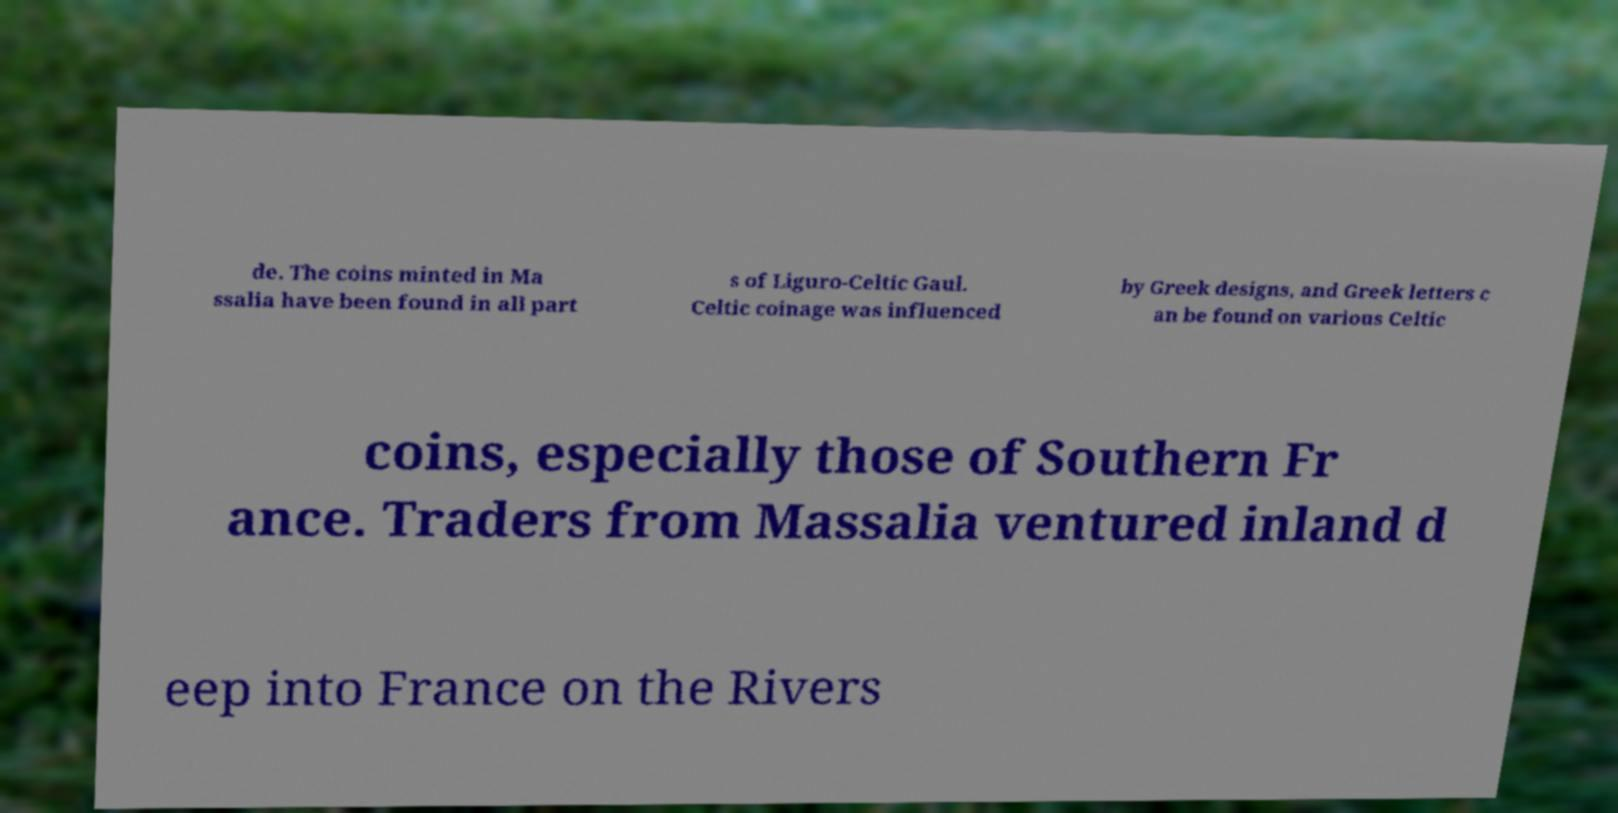Can you read and provide the text displayed in the image?This photo seems to have some interesting text. Can you extract and type it out for me? de. The coins minted in Ma ssalia have been found in all part s of Liguro-Celtic Gaul. Celtic coinage was influenced by Greek designs, and Greek letters c an be found on various Celtic coins, especially those of Southern Fr ance. Traders from Massalia ventured inland d eep into France on the Rivers 